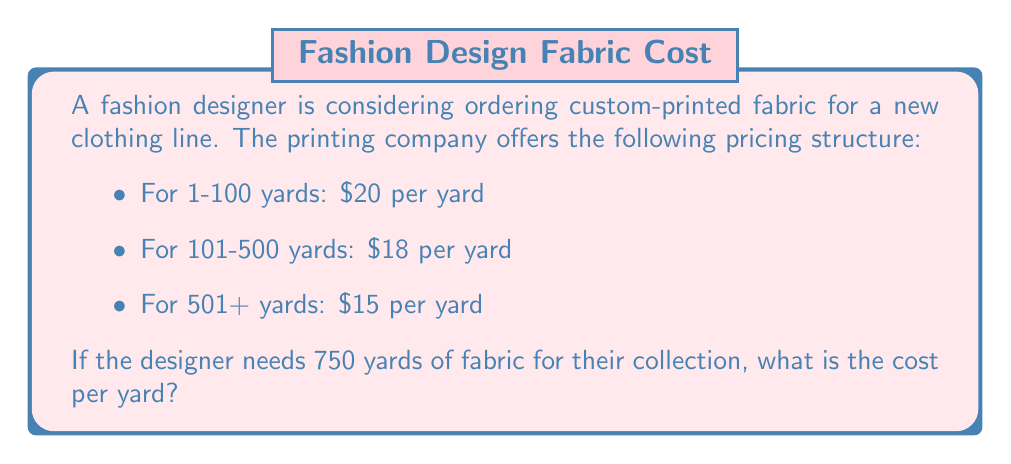Teach me how to tackle this problem. To solve this problem, we need to calculate the total cost for 750 yards and then divide it by the number of yards to find the cost per yard.

1. Break down the order into the pricing tiers:
   - First 100 yards at $20 per yard
   - Next 400 yards (101-500) at $18 per yard
   - Remaining 250 yards (501-750) at $15 per yard

2. Calculate the cost for each tier:
   - Tier 1: $100 \times $20 = $2,000$
   - Tier 2: $400 \times $18 = $7,200$
   - Tier 3: $250 \times $15 = $3,750$

3. Calculate the total cost:
   $\text{Total cost} = $2,000 + $7,200 + $3,750 = $12,950$

4. Calculate the cost per yard:
   $\text{Cost per yard} = \frac{\text{Total cost}}{\text{Total yards}} = \frac{$12,950}{750} = $17.27$ (rounded to the nearest cent)
Answer: The cost per yard for 750 yards of custom-printed fabric is $17.27. 